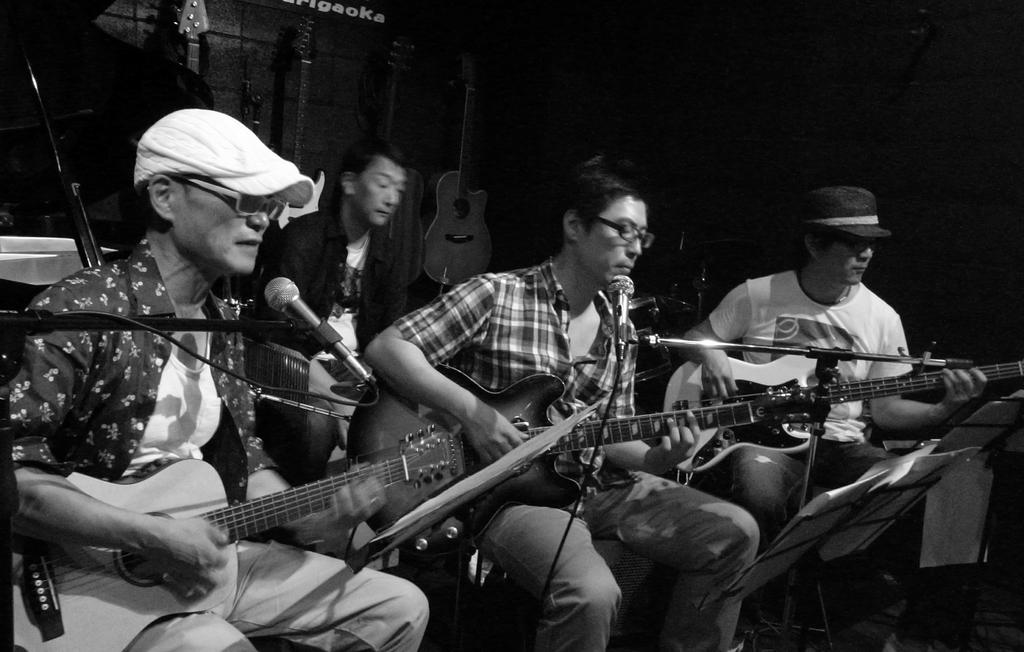How many people are in the image? There are four men in the image. What are the men doing in the image? The men are sitting in the image. What are three of the men holding? Three of the men are holding guitars. What objects are in front of the men? There are microphones in front of the men. What can be seen on the wall in the background of the image? There are guitars on the wall in the background of the image. What type of judge is present in the image? There is no judge present in the image; it features four men sitting with guitars and microphones. Can you tell me how many airports are visible in the image? There are no airports present in the image. 